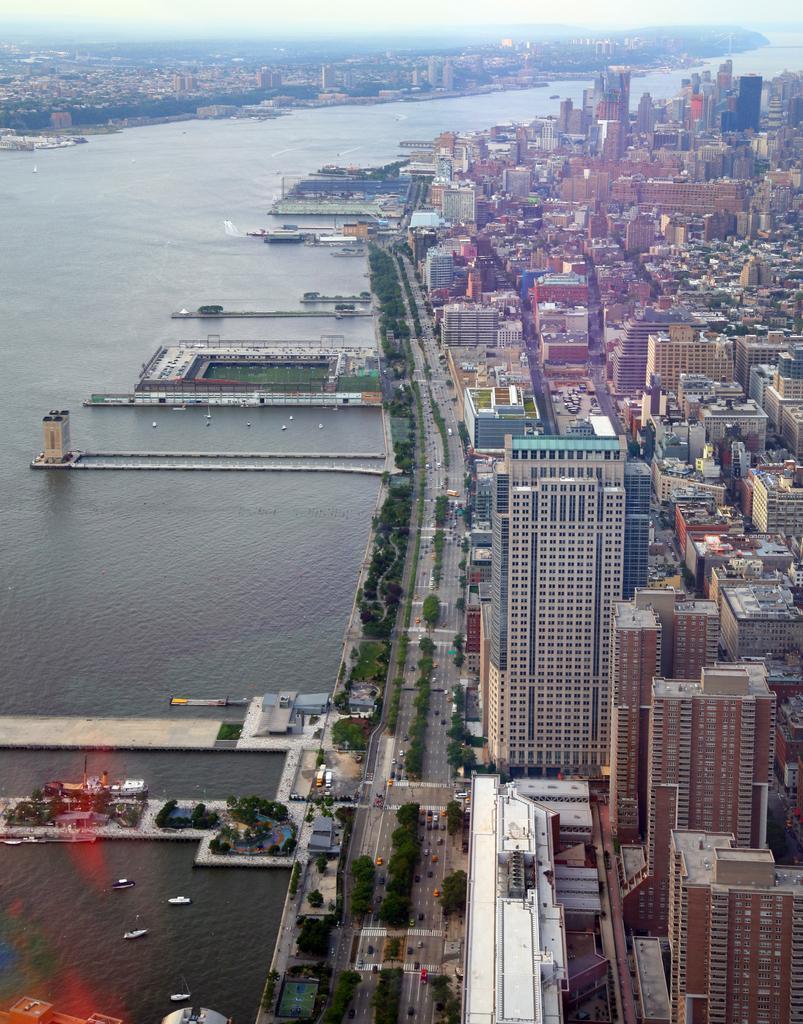In one or two sentences, can you explain what this image depicts? This is an aerial view in this image there are roads, trees, sea, buildings and the sky. 